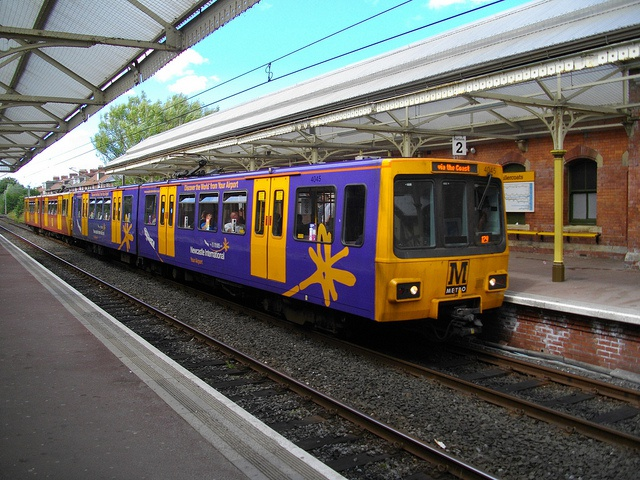Describe the objects in this image and their specific colors. I can see train in gray, black, navy, olive, and orange tones, bench in gray, olive, black, and gold tones, people in gray, black, darkgray, and maroon tones, people in gray, black, and olive tones, and people in gray, black, and navy tones in this image. 